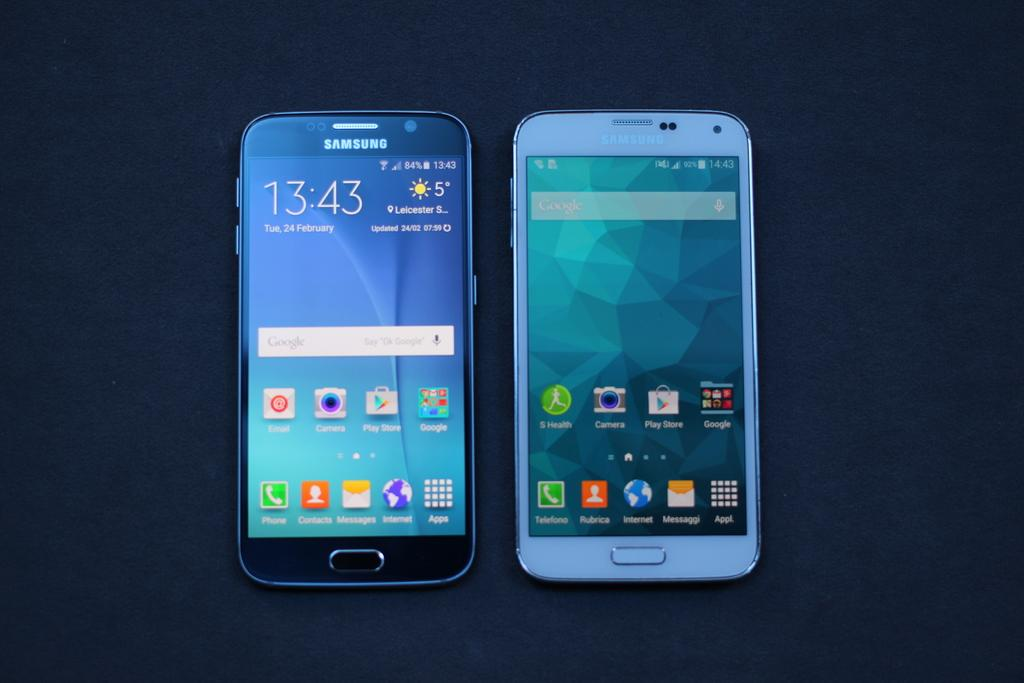<image>
Present a compact description of the photo's key features. Two Samsung cell phones displaying the home screens 